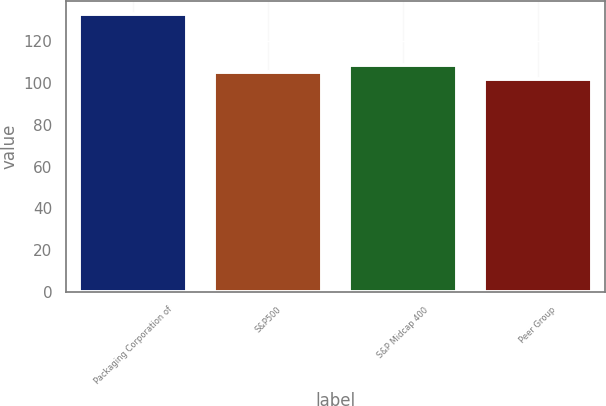Convert chart to OTSL. <chart><loc_0><loc_0><loc_500><loc_500><bar_chart><fcel>Packaging Corporation of<fcel>S&P500<fcel>S&P Midcap 400<fcel>Peer Group<nl><fcel>132.85<fcel>105.49<fcel>108.6<fcel>101.75<nl></chart> 